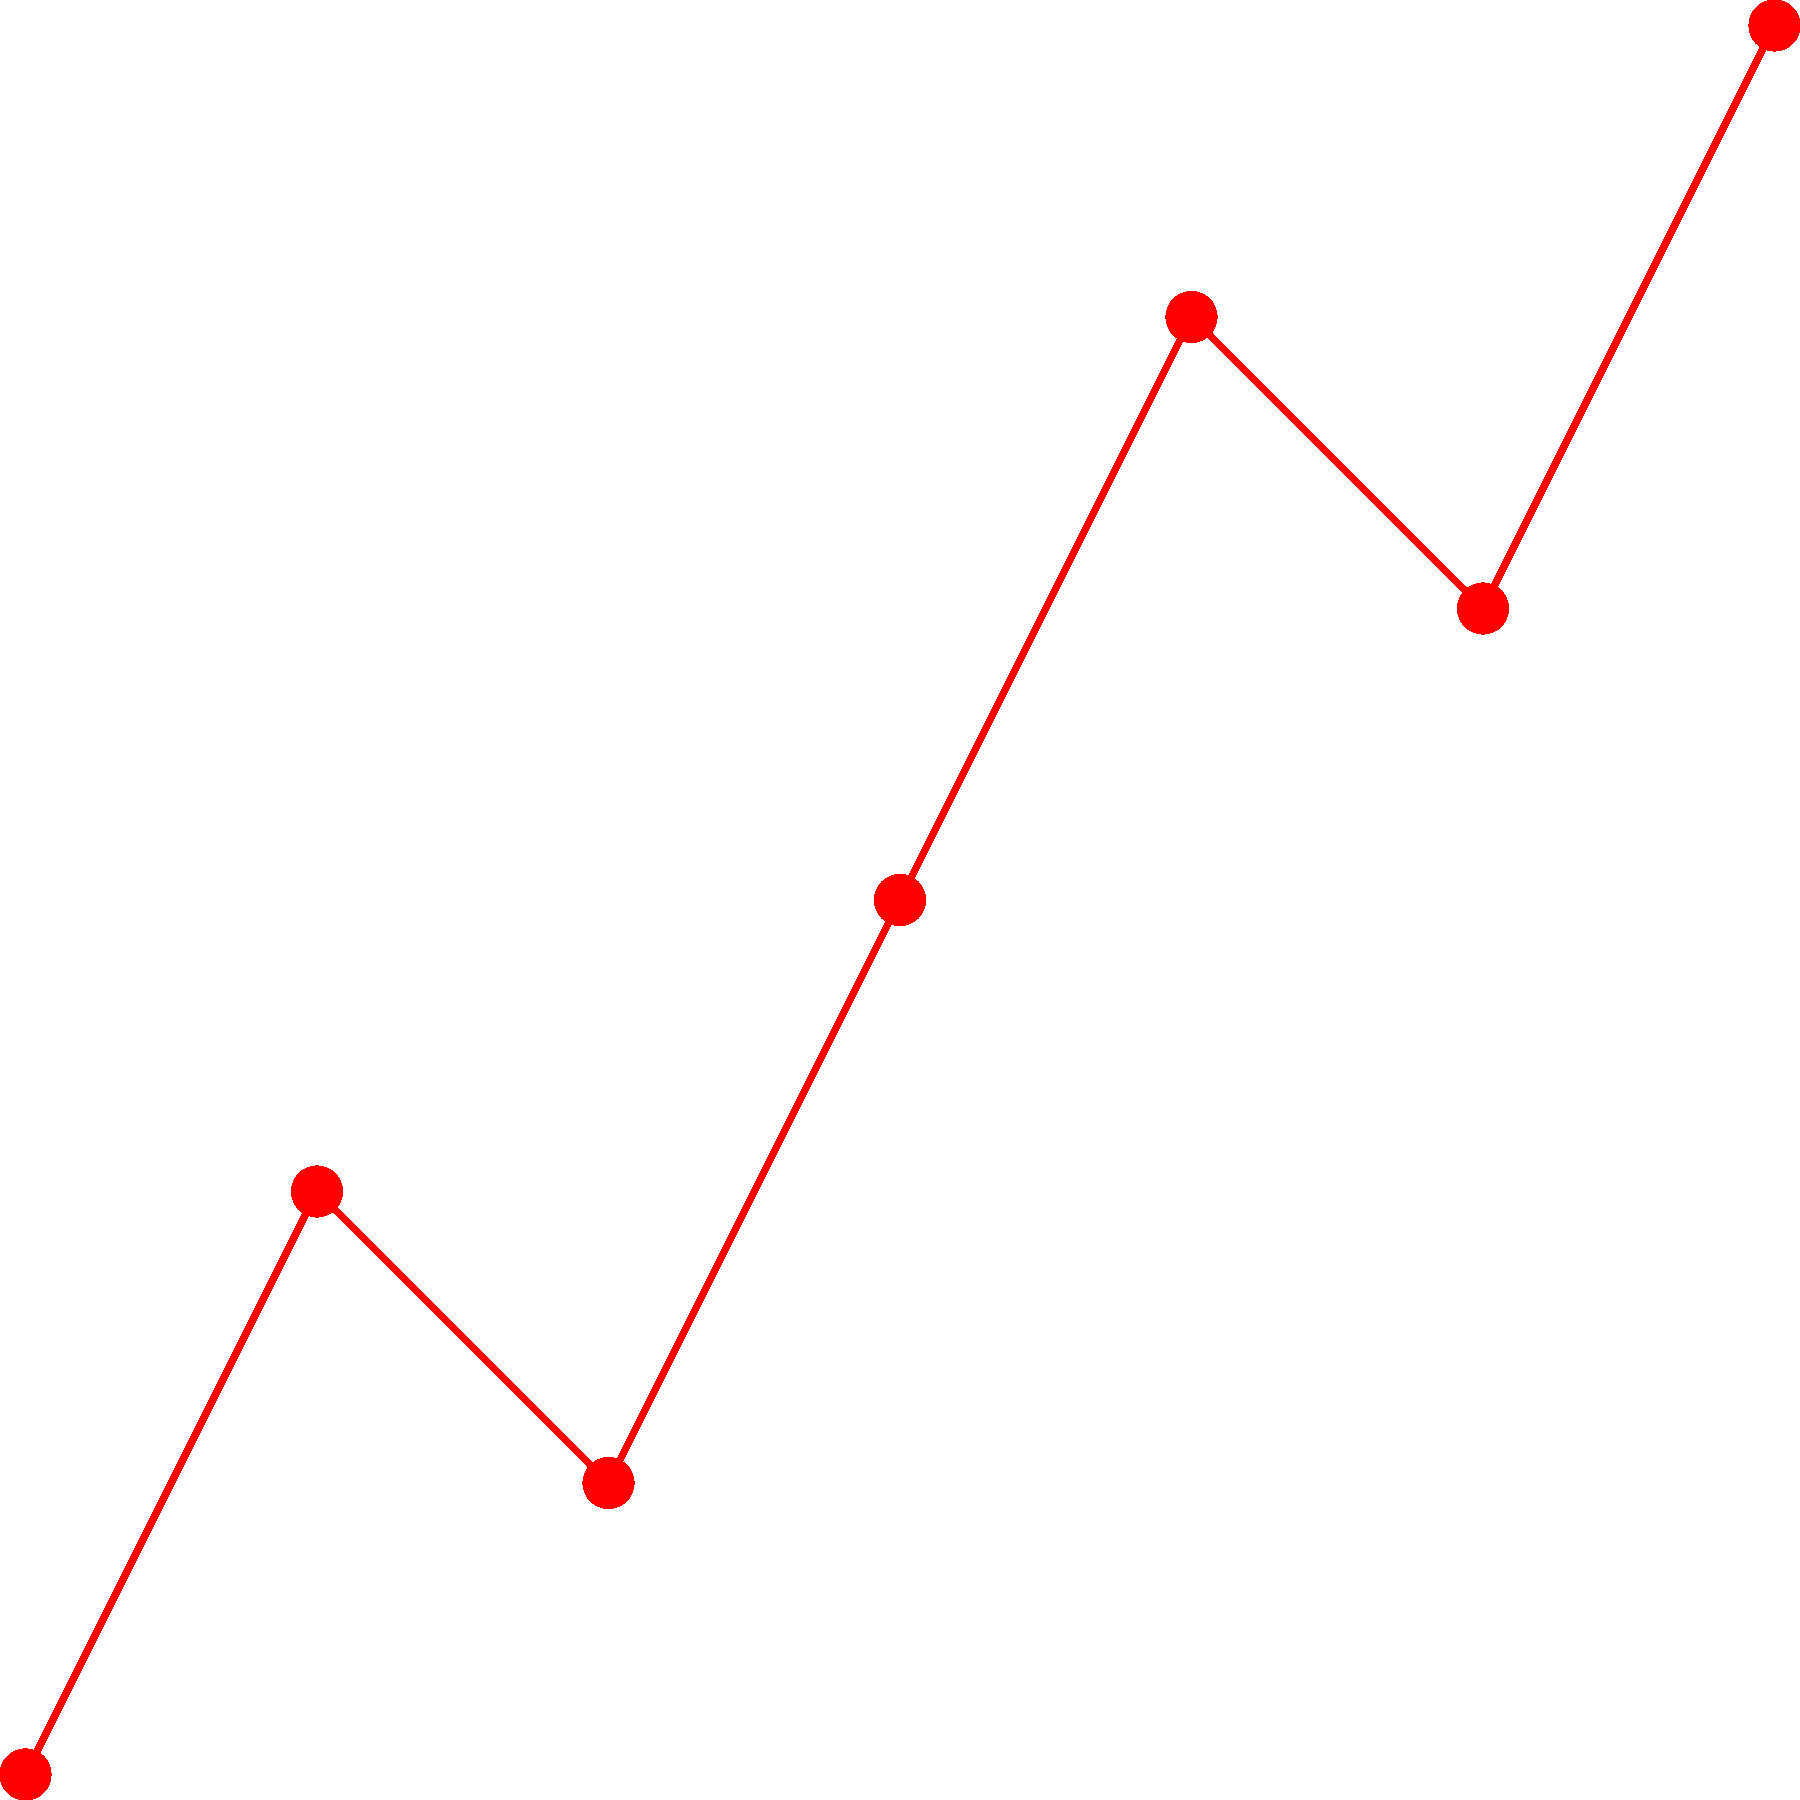Based on the timeline chart of suspicious money transfers and corporate events, which of the following statements is most likely to be true regarding the potential financial fraud? To analyze this timeline chart for potential financial fraud, let's follow these steps:

1. Observe the money transfer pattern (red line):
   - There's a general upward trend in transfer amounts over time.
   - Notable spikes occur at months 3 and 4.

2. Identify corporate events (blue crosses):
   - Month 2: Company A merger
   - Month 4: CEO resignation

3. Correlate transfers with events:
   - The first significant spike in transfers (month 3) follows immediately after the Company A merger.
   - The largest transfer amount coincides with the CEO resignation (month 4).

4. Analyze the timing and amounts:
   - The proximity of large transfers to major corporate events is suspicious.
   - The sudden increase in transfer amounts around these events suggests possible insider trading or embezzlement.

5. Consider the overall pattern:
   - The consistent increase in transfer amounts over time could indicate an escalating fraudulent scheme.
   - The drop in transfer amount after the CEO resignation might suggest an attempt to cover tracks or a change in the fraud operation.

Given these observations, the most likely statement regarding potential financial fraud would be that there's a strong correlation between corporate events and suspicious money transfers, particularly around the Company A merger and the CEO resignation. This pattern suggests possible insider trading or embezzlement related to these events.
Answer: Suspicious transfers correlate with corporate events, suggesting insider trading or embezzlement. 